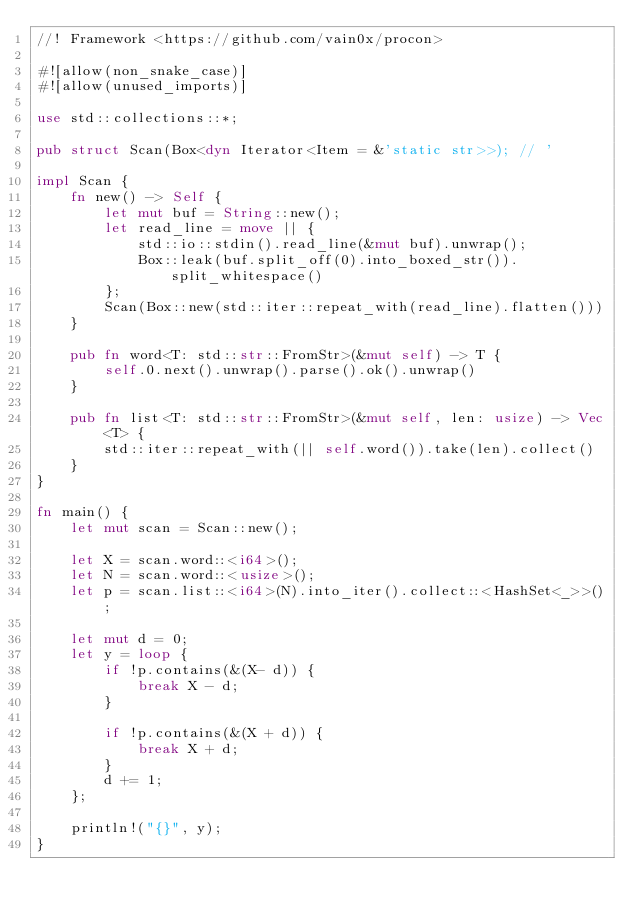Convert code to text. <code><loc_0><loc_0><loc_500><loc_500><_Rust_>//! Framework <https://github.com/vain0x/procon>

#![allow(non_snake_case)]
#![allow(unused_imports)]

use std::collections::*;

pub struct Scan(Box<dyn Iterator<Item = &'static str>>); // '

impl Scan {
    fn new() -> Self {
        let mut buf = String::new();
        let read_line = move || {
            std::io::stdin().read_line(&mut buf).unwrap();
            Box::leak(buf.split_off(0).into_boxed_str()).split_whitespace()
        };
        Scan(Box::new(std::iter::repeat_with(read_line).flatten()))
    }

    pub fn word<T: std::str::FromStr>(&mut self) -> T {
        self.0.next().unwrap().parse().ok().unwrap()
    }

    pub fn list<T: std::str::FromStr>(&mut self, len: usize) -> Vec<T> {
        std::iter::repeat_with(|| self.word()).take(len).collect()
    }
}

fn main() {
    let mut scan = Scan::new();

    let X = scan.word::<i64>();
    let N = scan.word::<usize>();
    let p = scan.list::<i64>(N).into_iter().collect::<HashSet<_>>();

    let mut d = 0;
    let y = loop {
        if !p.contains(&(X- d)) {
            break X - d;
        }

        if !p.contains(&(X + d)) {
            break X + d;
        }
        d += 1;
    };

    println!("{}", y);
}
</code> 